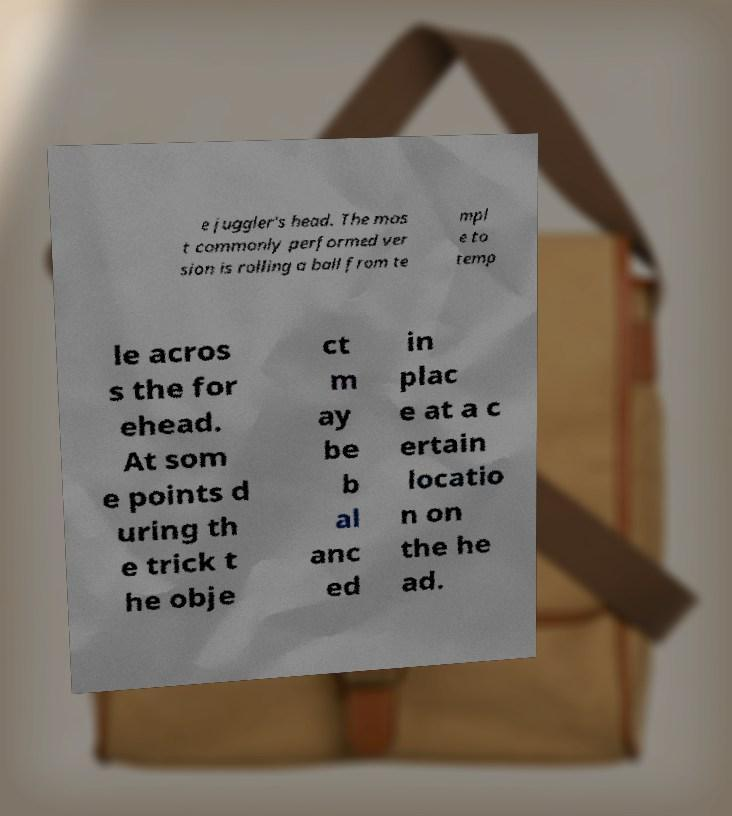There's text embedded in this image that I need extracted. Can you transcribe it verbatim? e juggler's head. The mos t commonly performed ver sion is rolling a ball from te mpl e to temp le acros s the for ehead. At som e points d uring th e trick t he obje ct m ay be b al anc ed in plac e at a c ertain locatio n on the he ad. 